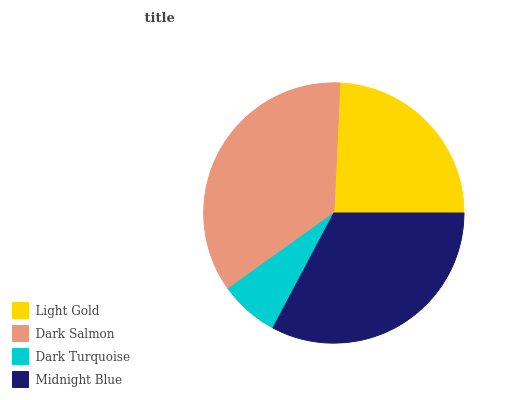Is Dark Turquoise the minimum?
Answer yes or no. Yes. Is Dark Salmon the maximum?
Answer yes or no. Yes. Is Dark Salmon the minimum?
Answer yes or no. No. Is Dark Turquoise the maximum?
Answer yes or no. No. Is Dark Salmon greater than Dark Turquoise?
Answer yes or no. Yes. Is Dark Turquoise less than Dark Salmon?
Answer yes or no. Yes. Is Dark Turquoise greater than Dark Salmon?
Answer yes or no. No. Is Dark Salmon less than Dark Turquoise?
Answer yes or no. No. Is Midnight Blue the high median?
Answer yes or no. Yes. Is Light Gold the low median?
Answer yes or no. Yes. Is Light Gold the high median?
Answer yes or no. No. Is Midnight Blue the low median?
Answer yes or no. No. 